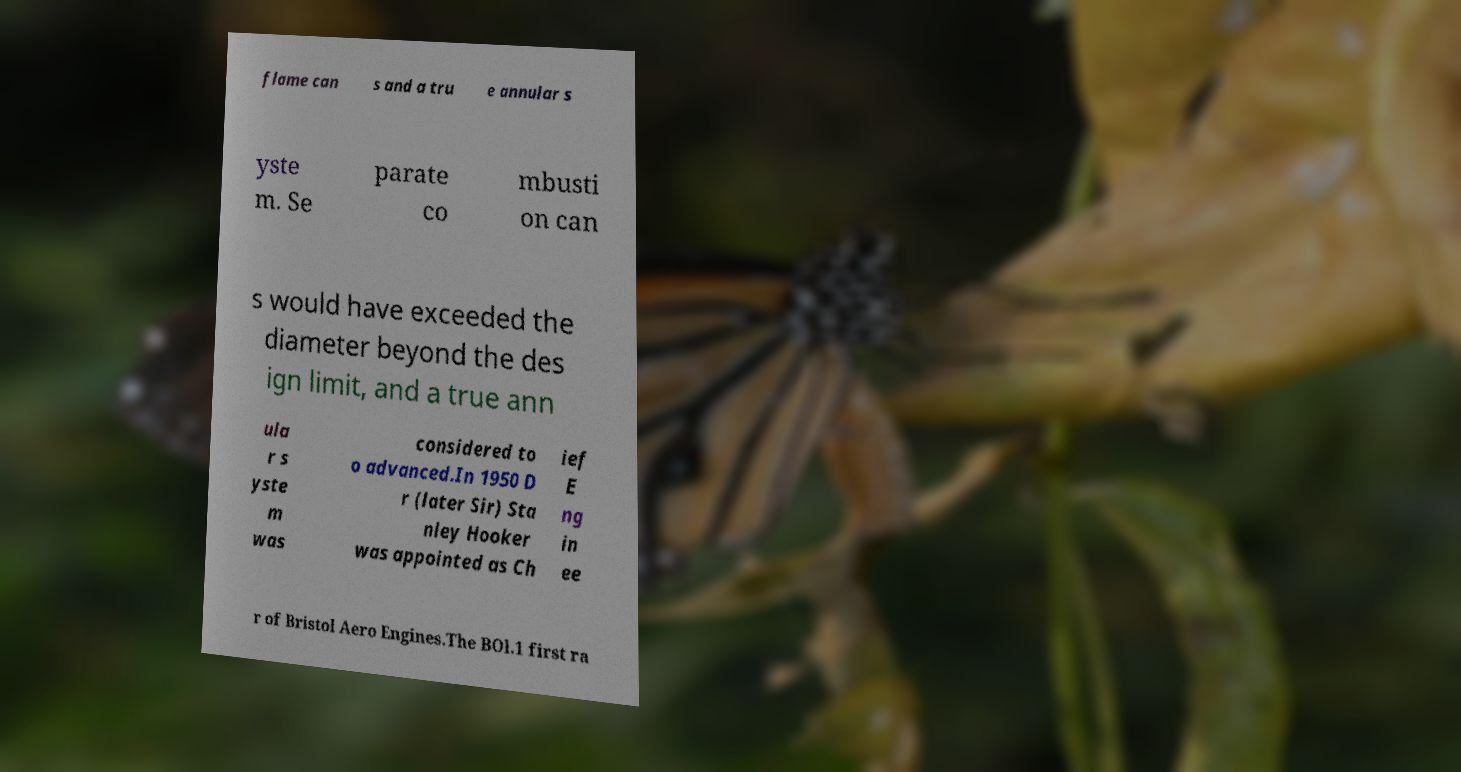I need the written content from this picture converted into text. Can you do that? flame can s and a tru e annular s yste m. Se parate co mbusti on can s would have exceeded the diameter beyond the des ign limit, and a true ann ula r s yste m was considered to o advanced.In 1950 D r (later Sir) Sta nley Hooker was appointed as Ch ief E ng in ee r of Bristol Aero Engines.The BOl.1 first ra 